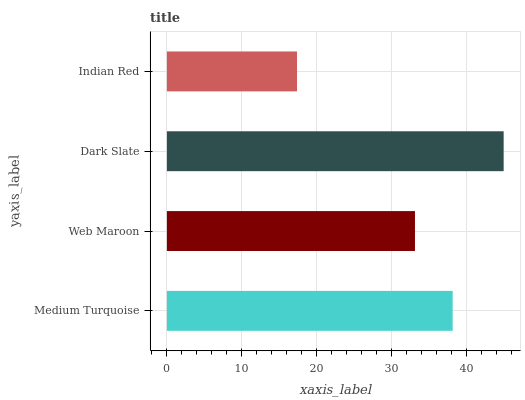Is Indian Red the minimum?
Answer yes or no. Yes. Is Dark Slate the maximum?
Answer yes or no. Yes. Is Web Maroon the minimum?
Answer yes or no. No. Is Web Maroon the maximum?
Answer yes or no. No. Is Medium Turquoise greater than Web Maroon?
Answer yes or no. Yes. Is Web Maroon less than Medium Turquoise?
Answer yes or no. Yes. Is Web Maroon greater than Medium Turquoise?
Answer yes or no. No. Is Medium Turquoise less than Web Maroon?
Answer yes or no. No. Is Medium Turquoise the high median?
Answer yes or no. Yes. Is Web Maroon the low median?
Answer yes or no. Yes. Is Dark Slate the high median?
Answer yes or no. No. Is Medium Turquoise the low median?
Answer yes or no. No. 